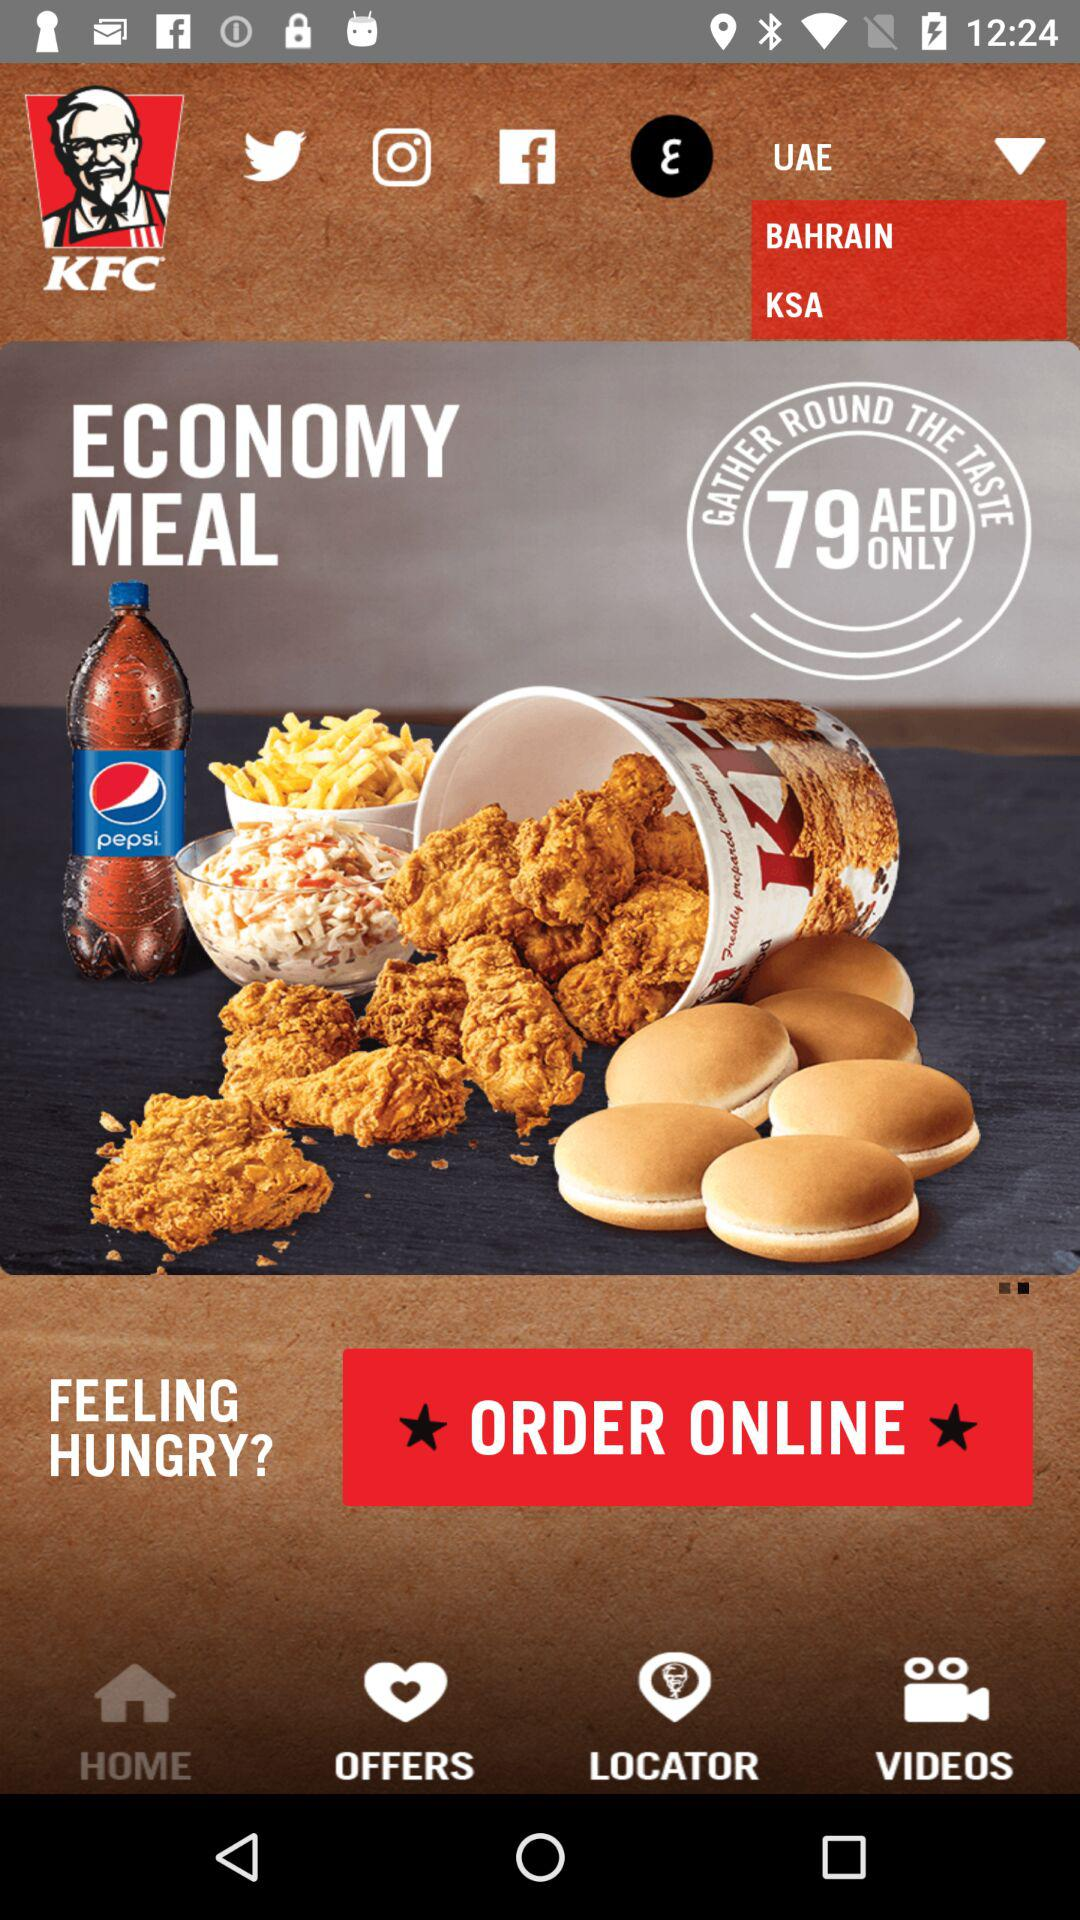How much does the economy meal cost? The economy meal costs only 79 AED. 